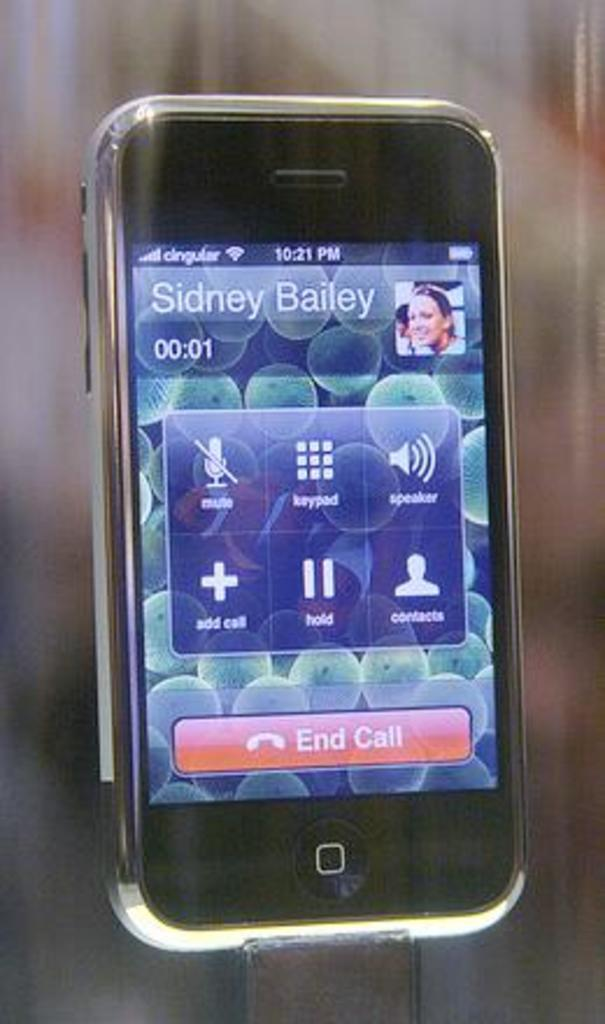<image>
Provide a brief description of the given image. A phone screen displays a call with Sidney Bailey. 